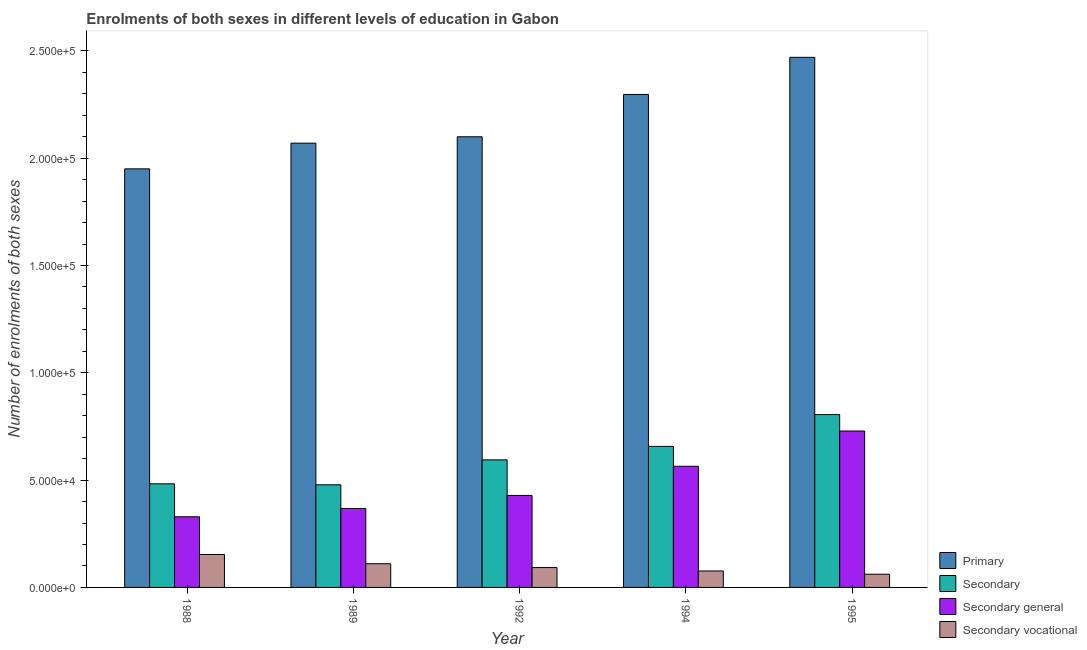How many different coloured bars are there?
Keep it short and to the point. 4. Are the number of bars per tick equal to the number of legend labels?
Provide a short and direct response. Yes. Are the number of bars on each tick of the X-axis equal?
Offer a very short reply. Yes. In how many cases, is the number of bars for a given year not equal to the number of legend labels?
Your response must be concise. 0. What is the number of enrolments in secondary education in 1994?
Give a very brief answer. 6.57e+04. Across all years, what is the maximum number of enrolments in secondary vocational education?
Ensure brevity in your answer.  1.54e+04. Across all years, what is the minimum number of enrolments in secondary education?
Offer a very short reply. 4.78e+04. In which year was the number of enrolments in secondary vocational education maximum?
Provide a succinct answer. 1988. What is the total number of enrolments in secondary education in the graph?
Offer a very short reply. 3.02e+05. What is the difference between the number of enrolments in primary education in 1992 and that in 1994?
Your answer should be very brief. -1.97e+04. What is the difference between the number of enrolments in primary education in 1992 and the number of enrolments in secondary education in 1988?
Make the answer very short. 1.50e+04. What is the average number of enrolments in secondary vocational education per year?
Your answer should be very brief. 9896.6. In how many years, is the number of enrolments in secondary vocational education greater than 230000?
Provide a short and direct response. 0. What is the ratio of the number of enrolments in secondary vocational education in 1994 to that in 1995?
Provide a short and direct response. 1.24. Is the number of enrolments in secondary vocational education in 1989 less than that in 1994?
Your answer should be very brief. No. What is the difference between the highest and the second highest number of enrolments in primary education?
Provide a short and direct response. 1.73e+04. What is the difference between the highest and the lowest number of enrolments in primary education?
Keep it short and to the point. 5.20e+04. In how many years, is the number of enrolments in secondary general education greater than the average number of enrolments in secondary general education taken over all years?
Your response must be concise. 2. Is the sum of the number of enrolments in secondary education in 1988 and 1989 greater than the maximum number of enrolments in primary education across all years?
Offer a very short reply. Yes. What does the 4th bar from the left in 1988 represents?
Your response must be concise. Secondary vocational. What does the 4th bar from the right in 1988 represents?
Give a very brief answer. Primary. Is it the case that in every year, the sum of the number of enrolments in primary education and number of enrolments in secondary education is greater than the number of enrolments in secondary general education?
Your response must be concise. Yes. How many years are there in the graph?
Your answer should be very brief. 5. What is the difference between two consecutive major ticks on the Y-axis?
Your answer should be very brief. 5.00e+04. Does the graph contain grids?
Your answer should be very brief. No. Where does the legend appear in the graph?
Provide a succinct answer. Bottom right. What is the title of the graph?
Provide a short and direct response. Enrolments of both sexes in different levels of education in Gabon. Does "Greece" appear as one of the legend labels in the graph?
Offer a terse response. No. What is the label or title of the Y-axis?
Provide a succinct answer. Number of enrolments of both sexes. What is the Number of enrolments of both sexes of Primary in 1988?
Offer a terse response. 1.95e+05. What is the Number of enrolments of both sexes in Secondary in 1988?
Make the answer very short. 4.83e+04. What is the Number of enrolments of both sexes of Secondary general in 1988?
Offer a very short reply. 3.29e+04. What is the Number of enrolments of both sexes in Secondary vocational in 1988?
Keep it short and to the point. 1.54e+04. What is the Number of enrolments of both sexes of Primary in 1989?
Ensure brevity in your answer.  2.07e+05. What is the Number of enrolments of both sexes in Secondary in 1989?
Your answer should be very brief. 4.78e+04. What is the Number of enrolments of both sexes in Secondary general in 1989?
Offer a very short reply. 3.68e+04. What is the Number of enrolments of both sexes in Secondary vocational in 1989?
Ensure brevity in your answer.  1.10e+04. What is the Number of enrolments of both sexes in Primary in 1992?
Your answer should be very brief. 2.10e+05. What is the Number of enrolments of both sexes in Secondary in 1992?
Keep it short and to the point. 5.94e+04. What is the Number of enrolments of both sexes in Secondary general in 1992?
Provide a short and direct response. 4.29e+04. What is the Number of enrolments of both sexes of Secondary vocational in 1992?
Keep it short and to the point. 9261. What is the Number of enrolments of both sexes in Primary in 1994?
Your response must be concise. 2.30e+05. What is the Number of enrolments of both sexes of Secondary in 1994?
Ensure brevity in your answer.  6.57e+04. What is the Number of enrolments of both sexes of Secondary general in 1994?
Keep it short and to the point. 5.65e+04. What is the Number of enrolments of both sexes of Secondary vocational in 1994?
Make the answer very short. 7664. What is the Number of enrolments of both sexes of Primary in 1995?
Provide a succinct answer. 2.47e+05. What is the Number of enrolments of both sexes of Secondary in 1995?
Make the answer very short. 8.06e+04. What is the Number of enrolments of both sexes in Secondary general in 1995?
Make the answer very short. 7.29e+04. What is the Number of enrolments of both sexes in Secondary vocational in 1995?
Make the answer very short. 6161. Across all years, what is the maximum Number of enrolments of both sexes of Primary?
Offer a very short reply. 2.47e+05. Across all years, what is the maximum Number of enrolments of both sexes of Secondary?
Your response must be concise. 8.06e+04. Across all years, what is the maximum Number of enrolments of both sexes of Secondary general?
Offer a very short reply. 7.29e+04. Across all years, what is the maximum Number of enrolments of both sexes of Secondary vocational?
Provide a succinct answer. 1.54e+04. Across all years, what is the minimum Number of enrolments of both sexes in Primary?
Make the answer very short. 1.95e+05. Across all years, what is the minimum Number of enrolments of both sexes of Secondary?
Offer a very short reply. 4.78e+04. Across all years, what is the minimum Number of enrolments of both sexes in Secondary general?
Give a very brief answer. 3.29e+04. Across all years, what is the minimum Number of enrolments of both sexes in Secondary vocational?
Give a very brief answer. 6161. What is the total Number of enrolments of both sexes of Primary in the graph?
Offer a very short reply. 1.09e+06. What is the total Number of enrolments of both sexes of Secondary in the graph?
Provide a short and direct response. 3.02e+05. What is the total Number of enrolments of both sexes in Secondary general in the graph?
Your response must be concise. 2.42e+05. What is the total Number of enrolments of both sexes in Secondary vocational in the graph?
Keep it short and to the point. 4.95e+04. What is the difference between the Number of enrolments of both sexes in Primary in 1988 and that in 1989?
Your response must be concise. -1.20e+04. What is the difference between the Number of enrolments of both sexes in Secondary in 1988 and that in 1989?
Give a very brief answer. 446. What is the difference between the Number of enrolments of both sexes in Secondary general in 1988 and that in 1989?
Provide a short and direct response. -3861. What is the difference between the Number of enrolments of both sexes of Secondary vocational in 1988 and that in 1989?
Provide a short and direct response. 4307. What is the difference between the Number of enrolments of both sexes of Primary in 1988 and that in 1992?
Provide a succinct answer. -1.50e+04. What is the difference between the Number of enrolments of both sexes of Secondary in 1988 and that in 1992?
Provide a short and direct response. -1.12e+04. What is the difference between the Number of enrolments of both sexes of Secondary general in 1988 and that in 1992?
Offer a terse response. -9949. What is the difference between the Number of enrolments of both sexes of Secondary vocational in 1988 and that in 1992?
Ensure brevity in your answer.  6091. What is the difference between the Number of enrolments of both sexes of Primary in 1988 and that in 1994?
Offer a terse response. -3.47e+04. What is the difference between the Number of enrolments of both sexes of Secondary in 1988 and that in 1994?
Ensure brevity in your answer.  -1.74e+04. What is the difference between the Number of enrolments of both sexes in Secondary general in 1988 and that in 1994?
Offer a very short reply. -2.35e+04. What is the difference between the Number of enrolments of both sexes of Secondary vocational in 1988 and that in 1994?
Offer a very short reply. 7688. What is the difference between the Number of enrolments of both sexes in Primary in 1988 and that in 1995?
Offer a very short reply. -5.20e+04. What is the difference between the Number of enrolments of both sexes in Secondary in 1988 and that in 1995?
Keep it short and to the point. -3.23e+04. What is the difference between the Number of enrolments of both sexes of Secondary general in 1988 and that in 1995?
Ensure brevity in your answer.  -4.00e+04. What is the difference between the Number of enrolments of both sexes of Secondary vocational in 1988 and that in 1995?
Your answer should be very brief. 9191. What is the difference between the Number of enrolments of both sexes of Primary in 1989 and that in 1992?
Make the answer very short. -2977. What is the difference between the Number of enrolments of both sexes in Secondary in 1989 and that in 1992?
Provide a succinct answer. -1.16e+04. What is the difference between the Number of enrolments of both sexes in Secondary general in 1989 and that in 1992?
Your response must be concise. -6088. What is the difference between the Number of enrolments of both sexes in Secondary vocational in 1989 and that in 1992?
Your response must be concise. 1784. What is the difference between the Number of enrolments of both sexes in Primary in 1989 and that in 1994?
Provide a short and direct response. -2.27e+04. What is the difference between the Number of enrolments of both sexes of Secondary in 1989 and that in 1994?
Provide a succinct answer. -1.79e+04. What is the difference between the Number of enrolments of both sexes of Secondary general in 1989 and that in 1994?
Provide a succinct answer. -1.97e+04. What is the difference between the Number of enrolments of both sexes of Secondary vocational in 1989 and that in 1994?
Your answer should be compact. 3381. What is the difference between the Number of enrolments of both sexes in Primary in 1989 and that in 1995?
Provide a short and direct response. -4.00e+04. What is the difference between the Number of enrolments of both sexes in Secondary in 1989 and that in 1995?
Make the answer very short. -3.27e+04. What is the difference between the Number of enrolments of both sexes of Secondary general in 1989 and that in 1995?
Provide a short and direct response. -3.61e+04. What is the difference between the Number of enrolments of both sexes of Secondary vocational in 1989 and that in 1995?
Your response must be concise. 4884. What is the difference between the Number of enrolments of both sexes in Primary in 1992 and that in 1994?
Provide a succinct answer. -1.97e+04. What is the difference between the Number of enrolments of both sexes of Secondary in 1992 and that in 1994?
Give a very brief answer. -6276. What is the difference between the Number of enrolments of both sexes in Secondary general in 1992 and that in 1994?
Your answer should be very brief. -1.36e+04. What is the difference between the Number of enrolments of both sexes of Secondary vocational in 1992 and that in 1994?
Keep it short and to the point. 1597. What is the difference between the Number of enrolments of both sexes in Primary in 1992 and that in 1995?
Offer a very short reply. -3.70e+04. What is the difference between the Number of enrolments of both sexes of Secondary in 1992 and that in 1995?
Your response must be concise. -2.11e+04. What is the difference between the Number of enrolments of both sexes of Secondary general in 1992 and that in 1995?
Offer a very short reply. -3.00e+04. What is the difference between the Number of enrolments of both sexes of Secondary vocational in 1992 and that in 1995?
Your response must be concise. 3100. What is the difference between the Number of enrolments of both sexes of Primary in 1994 and that in 1995?
Your response must be concise. -1.73e+04. What is the difference between the Number of enrolments of both sexes in Secondary in 1994 and that in 1995?
Offer a very short reply. -1.48e+04. What is the difference between the Number of enrolments of both sexes of Secondary general in 1994 and that in 1995?
Provide a short and direct response. -1.64e+04. What is the difference between the Number of enrolments of both sexes in Secondary vocational in 1994 and that in 1995?
Make the answer very short. 1503. What is the difference between the Number of enrolments of both sexes of Primary in 1988 and the Number of enrolments of both sexes of Secondary in 1989?
Offer a terse response. 1.47e+05. What is the difference between the Number of enrolments of both sexes in Primary in 1988 and the Number of enrolments of both sexes in Secondary general in 1989?
Your answer should be compact. 1.58e+05. What is the difference between the Number of enrolments of both sexes of Primary in 1988 and the Number of enrolments of both sexes of Secondary vocational in 1989?
Provide a succinct answer. 1.84e+05. What is the difference between the Number of enrolments of both sexes in Secondary in 1988 and the Number of enrolments of both sexes in Secondary general in 1989?
Offer a terse response. 1.15e+04. What is the difference between the Number of enrolments of both sexes of Secondary in 1988 and the Number of enrolments of both sexes of Secondary vocational in 1989?
Offer a terse response. 3.72e+04. What is the difference between the Number of enrolments of both sexes of Secondary general in 1988 and the Number of enrolments of both sexes of Secondary vocational in 1989?
Your response must be concise. 2.19e+04. What is the difference between the Number of enrolments of both sexes of Primary in 1988 and the Number of enrolments of both sexes of Secondary in 1992?
Make the answer very short. 1.36e+05. What is the difference between the Number of enrolments of both sexes in Primary in 1988 and the Number of enrolments of both sexes in Secondary general in 1992?
Keep it short and to the point. 1.52e+05. What is the difference between the Number of enrolments of both sexes of Primary in 1988 and the Number of enrolments of both sexes of Secondary vocational in 1992?
Ensure brevity in your answer.  1.86e+05. What is the difference between the Number of enrolments of both sexes in Secondary in 1988 and the Number of enrolments of both sexes in Secondary general in 1992?
Provide a succinct answer. 5403. What is the difference between the Number of enrolments of both sexes of Secondary in 1988 and the Number of enrolments of both sexes of Secondary vocational in 1992?
Provide a succinct answer. 3.90e+04. What is the difference between the Number of enrolments of both sexes in Secondary general in 1988 and the Number of enrolments of both sexes in Secondary vocational in 1992?
Provide a succinct answer. 2.37e+04. What is the difference between the Number of enrolments of both sexes in Primary in 1988 and the Number of enrolments of both sexes in Secondary in 1994?
Provide a short and direct response. 1.29e+05. What is the difference between the Number of enrolments of both sexes of Primary in 1988 and the Number of enrolments of both sexes of Secondary general in 1994?
Ensure brevity in your answer.  1.39e+05. What is the difference between the Number of enrolments of both sexes of Primary in 1988 and the Number of enrolments of both sexes of Secondary vocational in 1994?
Offer a very short reply. 1.87e+05. What is the difference between the Number of enrolments of both sexes of Secondary in 1988 and the Number of enrolments of both sexes of Secondary general in 1994?
Ensure brevity in your answer.  -8183. What is the difference between the Number of enrolments of both sexes in Secondary in 1988 and the Number of enrolments of both sexes in Secondary vocational in 1994?
Your answer should be compact. 4.06e+04. What is the difference between the Number of enrolments of both sexes of Secondary general in 1988 and the Number of enrolments of both sexes of Secondary vocational in 1994?
Make the answer very short. 2.53e+04. What is the difference between the Number of enrolments of both sexes of Primary in 1988 and the Number of enrolments of both sexes of Secondary in 1995?
Offer a terse response. 1.14e+05. What is the difference between the Number of enrolments of both sexes in Primary in 1988 and the Number of enrolments of both sexes in Secondary general in 1995?
Make the answer very short. 1.22e+05. What is the difference between the Number of enrolments of both sexes in Primary in 1988 and the Number of enrolments of both sexes in Secondary vocational in 1995?
Keep it short and to the point. 1.89e+05. What is the difference between the Number of enrolments of both sexes of Secondary in 1988 and the Number of enrolments of both sexes of Secondary general in 1995?
Provide a short and direct response. -2.46e+04. What is the difference between the Number of enrolments of both sexes of Secondary in 1988 and the Number of enrolments of both sexes of Secondary vocational in 1995?
Provide a succinct answer. 4.21e+04. What is the difference between the Number of enrolments of both sexes of Secondary general in 1988 and the Number of enrolments of both sexes of Secondary vocational in 1995?
Make the answer very short. 2.68e+04. What is the difference between the Number of enrolments of both sexes in Primary in 1989 and the Number of enrolments of both sexes in Secondary in 1992?
Keep it short and to the point. 1.48e+05. What is the difference between the Number of enrolments of both sexes in Primary in 1989 and the Number of enrolments of both sexes in Secondary general in 1992?
Keep it short and to the point. 1.64e+05. What is the difference between the Number of enrolments of both sexes in Primary in 1989 and the Number of enrolments of both sexes in Secondary vocational in 1992?
Make the answer very short. 1.98e+05. What is the difference between the Number of enrolments of both sexes of Secondary in 1989 and the Number of enrolments of both sexes of Secondary general in 1992?
Keep it short and to the point. 4957. What is the difference between the Number of enrolments of both sexes of Secondary in 1989 and the Number of enrolments of both sexes of Secondary vocational in 1992?
Your answer should be compact. 3.86e+04. What is the difference between the Number of enrolments of both sexes of Secondary general in 1989 and the Number of enrolments of both sexes of Secondary vocational in 1992?
Keep it short and to the point. 2.75e+04. What is the difference between the Number of enrolments of both sexes of Primary in 1989 and the Number of enrolments of both sexes of Secondary in 1994?
Provide a succinct answer. 1.41e+05. What is the difference between the Number of enrolments of both sexes in Primary in 1989 and the Number of enrolments of both sexes in Secondary general in 1994?
Give a very brief answer. 1.51e+05. What is the difference between the Number of enrolments of both sexes in Primary in 1989 and the Number of enrolments of both sexes in Secondary vocational in 1994?
Your response must be concise. 1.99e+05. What is the difference between the Number of enrolments of both sexes in Secondary in 1989 and the Number of enrolments of both sexes in Secondary general in 1994?
Offer a terse response. -8629. What is the difference between the Number of enrolments of both sexes of Secondary in 1989 and the Number of enrolments of both sexes of Secondary vocational in 1994?
Your answer should be very brief. 4.02e+04. What is the difference between the Number of enrolments of both sexes of Secondary general in 1989 and the Number of enrolments of both sexes of Secondary vocational in 1994?
Ensure brevity in your answer.  2.91e+04. What is the difference between the Number of enrolments of both sexes in Primary in 1989 and the Number of enrolments of both sexes in Secondary in 1995?
Provide a short and direct response. 1.26e+05. What is the difference between the Number of enrolments of both sexes in Primary in 1989 and the Number of enrolments of both sexes in Secondary general in 1995?
Provide a succinct answer. 1.34e+05. What is the difference between the Number of enrolments of both sexes of Primary in 1989 and the Number of enrolments of both sexes of Secondary vocational in 1995?
Provide a short and direct response. 2.01e+05. What is the difference between the Number of enrolments of both sexes of Secondary in 1989 and the Number of enrolments of both sexes of Secondary general in 1995?
Ensure brevity in your answer.  -2.51e+04. What is the difference between the Number of enrolments of both sexes in Secondary in 1989 and the Number of enrolments of both sexes in Secondary vocational in 1995?
Your response must be concise. 4.17e+04. What is the difference between the Number of enrolments of both sexes of Secondary general in 1989 and the Number of enrolments of both sexes of Secondary vocational in 1995?
Provide a succinct answer. 3.06e+04. What is the difference between the Number of enrolments of both sexes of Primary in 1992 and the Number of enrolments of both sexes of Secondary in 1994?
Provide a succinct answer. 1.44e+05. What is the difference between the Number of enrolments of both sexes of Primary in 1992 and the Number of enrolments of both sexes of Secondary general in 1994?
Your answer should be compact. 1.54e+05. What is the difference between the Number of enrolments of both sexes in Primary in 1992 and the Number of enrolments of both sexes in Secondary vocational in 1994?
Your answer should be very brief. 2.02e+05. What is the difference between the Number of enrolments of both sexes in Secondary in 1992 and the Number of enrolments of both sexes in Secondary general in 1994?
Your answer should be very brief. 2985. What is the difference between the Number of enrolments of both sexes in Secondary in 1992 and the Number of enrolments of both sexes in Secondary vocational in 1994?
Provide a short and direct response. 5.18e+04. What is the difference between the Number of enrolments of both sexes of Secondary general in 1992 and the Number of enrolments of both sexes of Secondary vocational in 1994?
Give a very brief answer. 3.52e+04. What is the difference between the Number of enrolments of both sexes of Primary in 1992 and the Number of enrolments of both sexes of Secondary in 1995?
Your answer should be compact. 1.29e+05. What is the difference between the Number of enrolments of both sexes of Primary in 1992 and the Number of enrolments of both sexes of Secondary general in 1995?
Give a very brief answer. 1.37e+05. What is the difference between the Number of enrolments of both sexes of Primary in 1992 and the Number of enrolments of both sexes of Secondary vocational in 1995?
Make the answer very short. 2.04e+05. What is the difference between the Number of enrolments of both sexes in Secondary in 1992 and the Number of enrolments of both sexes in Secondary general in 1995?
Offer a very short reply. -1.34e+04. What is the difference between the Number of enrolments of both sexes of Secondary in 1992 and the Number of enrolments of both sexes of Secondary vocational in 1995?
Your answer should be very brief. 5.33e+04. What is the difference between the Number of enrolments of both sexes in Secondary general in 1992 and the Number of enrolments of both sexes in Secondary vocational in 1995?
Keep it short and to the point. 3.67e+04. What is the difference between the Number of enrolments of both sexes of Primary in 1994 and the Number of enrolments of both sexes of Secondary in 1995?
Make the answer very short. 1.49e+05. What is the difference between the Number of enrolments of both sexes of Primary in 1994 and the Number of enrolments of both sexes of Secondary general in 1995?
Your answer should be compact. 1.57e+05. What is the difference between the Number of enrolments of both sexes in Primary in 1994 and the Number of enrolments of both sexes in Secondary vocational in 1995?
Provide a short and direct response. 2.24e+05. What is the difference between the Number of enrolments of both sexes in Secondary in 1994 and the Number of enrolments of both sexes in Secondary general in 1995?
Your response must be concise. -7170. What is the difference between the Number of enrolments of both sexes of Secondary in 1994 and the Number of enrolments of both sexes of Secondary vocational in 1995?
Your answer should be compact. 5.96e+04. What is the difference between the Number of enrolments of both sexes of Secondary general in 1994 and the Number of enrolments of both sexes of Secondary vocational in 1995?
Provide a succinct answer. 5.03e+04. What is the average Number of enrolments of both sexes of Primary per year?
Your answer should be very brief. 2.18e+05. What is the average Number of enrolments of both sexes in Secondary per year?
Give a very brief answer. 6.04e+04. What is the average Number of enrolments of both sexes in Secondary general per year?
Make the answer very short. 4.84e+04. What is the average Number of enrolments of both sexes in Secondary vocational per year?
Ensure brevity in your answer.  9896.6. In the year 1988, what is the difference between the Number of enrolments of both sexes of Primary and Number of enrolments of both sexes of Secondary?
Ensure brevity in your answer.  1.47e+05. In the year 1988, what is the difference between the Number of enrolments of both sexes in Primary and Number of enrolments of both sexes in Secondary general?
Keep it short and to the point. 1.62e+05. In the year 1988, what is the difference between the Number of enrolments of both sexes of Primary and Number of enrolments of both sexes of Secondary vocational?
Offer a terse response. 1.80e+05. In the year 1988, what is the difference between the Number of enrolments of both sexes in Secondary and Number of enrolments of both sexes in Secondary general?
Your answer should be very brief. 1.54e+04. In the year 1988, what is the difference between the Number of enrolments of both sexes of Secondary and Number of enrolments of both sexes of Secondary vocational?
Your answer should be very brief. 3.29e+04. In the year 1988, what is the difference between the Number of enrolments of both sexes of Secondary general and Number of enrolments of both sexes of Secondary vocational?
Your answer should be compact. 1.76e+04. In the year 1989, what is the difference between the Number of enrolments of both sexes of Primary and Number of enrolments of both sexes of Secondary?
Your answer should be compact. 1.59e+05. In the year 1989, what is the difference between the Number of enrolments of both sexes in Primary and Number of enrolments of both sexes in Secondary general?
Your answer should be compact. 1.70e+05. In the year 1989, what is the difference between the Number of enrolments of both sexes in Primary and Number of enrolments of both sexes in Secondary vocational?
Provide a succinct answer. 1.96e+05. In the year 1989, what is the difference between the Number of enrolments of both sexes in Secondary and Number of enrolments of both sexes in Secondary general?
Ensure brevity in your answer.  1.10e+04. In the year 1989, what is the difference between the Number of enrolments of both sexes of Secondary and Number of enrolments of both sexes of Secondary vocational?
Offer a terse response. 3.68e+04. In the year 1989, what is the difference between the Number of enrolments of both sexes in Secondary general and Number of enrolments of both sexes in Secondary vocational?
Make the answer very short. 2.57e+04. In the year 1992, what is the difference between the Number of enrolments of both sexes in Primary and Number of enrolments of both sexes in Secondary?
Offer a very short reply. 1.51e+05. In the year 1992, what is the difference between the Number of enrolments of both sexes of Primary and Number of enrolments of both sexes of Secondary general?
Provide a succinct answer. 1.67e+05. In the year 1992, what is the difference between the Number of enrolments of both sexes of Primary and Number of enrolments of both sexes of Secondary vocational?
Provide a short and direct response. 2.01e+05. In the year 1992, what is the difference between the Number of enrolments of both sexes in Secondary and Number of enrolments of both sexes in Secondary general?
Make the answer very short. 1.66e+04. In the year 1992, what is the difference between the Number of enrolments of both sexes in Secondary and Number of enrolments of both sexes in Secondary vocational?
Offer a terse response. 5.02e+04. In the year 1992, what is the difference between the Number of enrolments of both sexes of Secondary general and Number of enrolments of both sexes of Secondary vocational?
Your response must be concise. 3.36e+04. In the year 1994, what is the difference between the Number of enrolments of both sexes of Primary and Number of enrolments of both sexes of Secondary?
Your response must be concise. 1.64e+05. In the year 1994, what is the difference between the Number of enrolments of both sexes of Primary and Number of enrolments of both sexes of Secondary general?
Your answer should be very brief. 1.73e+05. In the year 1994, what is the difference between the Number of enrolments of both sexes of Primary and Number of enrolments of both sexes of Secondary vocational?
Provide a succinct answer. 2.22e+05. In the year 1994, what is the difference between the Number of enrolments of both sexes in Secondary and Number of enrolments of both sexes in Secondary general?
Your answer should be very brief. 9261. In the year 1994, what is the difference between the Number of enrolments of both sexes of Secondary and Number of enrolments of both sexes of Secondary vocational?
Provide a short and direct response. 5.81e+04. In the year 1994, what is the difference between the Number of enrolments of both sexes of Secondary general and Number of enrolments of both sexes of Secondary vocational?
Your answer should be compact. 4.88e+04. In the year 1995, what is the difference between the Number of enrolments of both sexes in Primary and Number of enrolments of both sexes in Secondary?
Your response must be concise. 1.66e+05. In the year 1995, what is the difference between the Number of enrolments of both sexes of Primary and Number of enrolments of both sexes of Secondary general?
Ensure brevity in your answer.  1.74e+05. In the year 1995, what is the difference between the Number of enrolments of both sexes in Primary and Number of enrolments of both sexes in Secondary vocational?
Your answer should be compact. 2.41e+05. In the year 1995, what is the difference between the Number of enrolments of both sexes of Secondary and Number of enrolments of both sexes of Secondary general?
Give a very brief answer. 7664. In the year 1995, what is the difference between the Number of enrolments of both sexes in Secondary and Number of enrolments of both sexes in Secondary vocational?
Offer a terse response. 7.44e+04. In the year 1995, what is the difference between the Number of enrolments of both sexes in Secondary general and Number of enrolments of both sexes in Secondary vocational?
Your answer should be very brief. 6.67e+04. What is the ratio of the Number of enrolments of both sexes of Primary in 1988 to that in 1989?
Provide a succinct answer. 0.94. What is the ratio of the Number of enrolments of both sexes of Secondary in 1988 to that in 1989?
Provide a short and direct response. 1.01. What is the ratio of the Number of enrolments of both sexes of Secondary general in 1988 to that in 1989?
Offer a very short reply. 0.9. What is the ratio of the Number of enrolments of both sexes of Secondary vocational in 1988 to that in 1989?
Offer a very short reply. 1.39. What is the ratio of the Number of enrolments of both sexes of Primary in 1988 to that in 1992?
Offer a terse response. 0.93. What is the ratio of the Number of enrolments of both sexes in Secondary in 1988 to that in 1992?
Offer a very short reply. 0.81. What is the ratio of the Number of enrolments of both sexes in Secondary general in 1988 to that in 1992?
Keep it short and to the point. 0.77. What is the ratio of the Number of enrolments of both sexes of Secondary vocational in 1988 to that in 1992?
Offer a terse response. 1.66. What is the ratio of the Number of enrolments of both sexes in Primary in 1988 to that in 1994?
Give a very brief answer. 0.85. What is the ratio of the Number of enrolments of both sexes of Secondary in 1988 to that in 1994?
Your answer should be very brief. 0.73. What is the ratio of the Number of enrolments of both sexes in Secondary general in 1988 to that in 1994?
Provide a succinct answer. 0.58. What is the ratio of the Number of enrolments of both sexes in Secondary vocational in 1988 to that in 1994?
Your answer should be very brief. 2. What is the ratio of the Number of enrolments of both sexes in Primary in 1988 to that in 1995?
Your answer should be very brief. 0.79. What is the ratio of the Number of enrolments of both sexes in Secondary in 1988 to that in 1995?
Your answer should be compact. 0.6. What is the ratio of the Number of enrolments of both sexes in Secondary general in 1988 to that in 1995?
Offer a very short reply. 0.45. What is the ratio of the Number of enrolments of both sexes of Secondary vocational in 1988 to that in 1995?
Provide a short and direct response. 2.49. What is the ratio of the Number of enrolments of both sexes in Primary in 1989 to that in 1992?
Your response must be concise. 0.99. What is the ratio of the Number of enrolments of both sexes in Secondary in 1989 to that in 1992?
Your response must be concise. 0.8. What is the ratio of the Number of enrolments of both sexes in Secondary general in 1989 to that in 1992?
Offer a terse response. 0.86. What is the ratio of the Number of enrolments of both sexes of Secondary vocational in 1989 to that in 1992?
Keep it short and to the point. 1.19. What is the ratio of the Number of enrolments of both sexes of Primary in 1989 to that in 1994?
Make the answer very short. 0.9. What is the ratio of the Number of enrolments of both sexes of Secondary in 1989 to that in 1994?
Provide a succinct answer. 0.73. What is the ratio of the Number of enrolments of both sexes in Secondary general in 1989 to that in 1994?
Offer a very short reply. 0.65. What is the ratio of the Number of enrolments of both sexes of Secondary vocational in 1989 to that in 1994?
Make the answer very short. 1.44. What is the ratio of the Number of enrolments of both sexes of Primary in 1989 to that in 1995?
Give a very brief answer. 0.84. What is the ratio of the Number of enrolments of both sexes of Secondary in 1989 to that in 1995?
Keep it short and to the point. 0.59. What is the ratio of the Number of enrolments of both sexes of Secondary general in 1989 to that in 1995?
Provide a short and direct response. 0.5. What is the ratio of the Number of enrolments of both sexes in Secondary vocational in 1989 to that in 1995?
Provide a short and direct response. 1.79. What is the ratio of the Number of enrolments of both sexes in Primary in 1992 to that in 1994?
Your answer should be compact. 0.91. What is the ratio of the Number of enrolments of both sexes in Secondary in 1992 to that in 1994?
Your response must be concise. 0.9. What is the ratio of the Number of enrolments of both sexes in Secondary general in 1992 to that in 1994?
Provide a short and direct response. 0.76. What is the ratio of the Number of enrolments of both sexes of Secondary vocational in 1992 to that in 1994?
Offer a terse response. 1.21. What is the ratio of the Number of enrolments of both sexes of Primary in 1992 to that in 1995?
Give a very brief answer. 0.85. What is the ratio of the Number of enrolments of both sexes of Secondary in 1992 to that in 1995?
Provide a short and direct response. 0.74. What is the ratio of the Number of enrolments of both sexes of Secondary general in 1992 to that in 1995?
Your answer should be compact. 0.59. What is the ratio of the Number of enrolments of both sexes of Secondary vocational in 1992 to that in 1995?
Provide a succinct answer. 1.5. What is the ratio of the Number of enrolments of both sexes in Primary in 1994 to that in 1995?
Provide a succinct answer. 0.93. What is the ratio of the Number of enrolments of both sexes of Secondary in 1994 to that in 1995?
Keep it short and to the point. 0.82. What is the ratio of the Number of enrolments of both sexes in Secondary general in 1994 to that in 1995?
Provide a short and direct response. 0.77. What is the ratio of the Number of enrolments of both sexes of Secondary vocational in 1994 to that in 1995?
Offer a very short reply. 1.24. What is the difference between the highest and the second highest Number of enrolments of both sexes of Primary?
Give a very brief answer. 1.73e+04. What is the difference between the highest and the second highest Number of enrolments of both sexes in Secondary?
Your answer should be very brief. 1.48e+04. What is the difference between the highest and the second highest Number of enrolments of both sexes of Secondary general?
Provide a short and direct response. 1.64e+04. What is the difference between the highest and the second highest Number of enrolments of both sexes in Secondary vocational?
Your answer should be very brief. 4307. What is the difference between the highest and the lowest Number of enrolments of both sexes in Primary?
Keep it short and to the point. 5.20e+04. What is the difference between the highest and the lowest Number of enrolments of both sexes in Secondary?
Your response must be concise. 3.27e+04. What is the difference between the highest and the lowest Number of enrolments of both sexes of Secondary general?
Provide a succinct answer. 4.00e+04. What is the difference between the highest and the lowest Number of enrolments of both sexes of Secondary vocational?
Provide a short and direct response. 9191. 